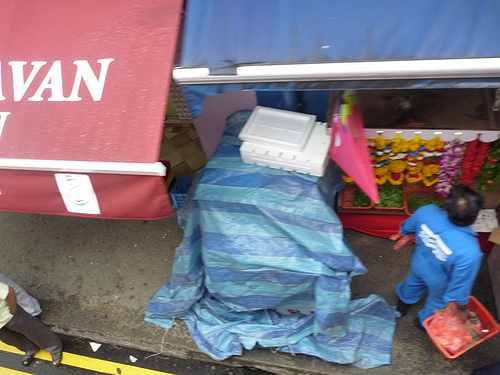<image>
Is the vegetable in the basket? No. The vegetable is not contained within the basket. These objects have a different spatial relationship. 